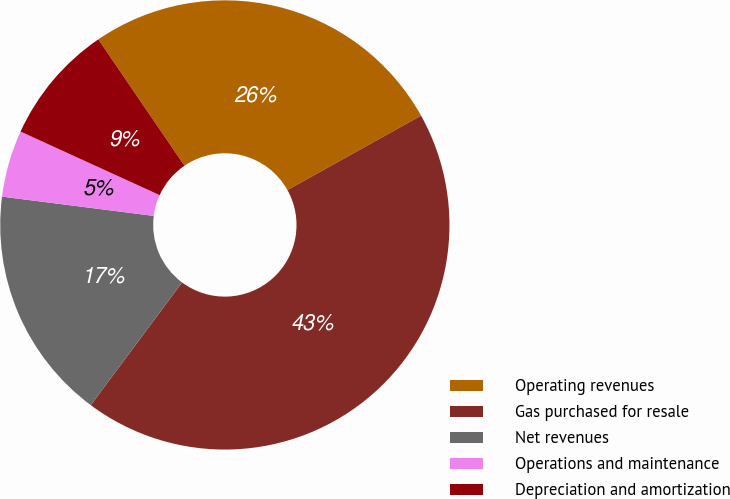<chart> <loc_0><loc_0><loc_500><loc_500><pie_chart><fcel>Operating revenues<fcel>Gas purchased for resale<fcel>Net revenues<fcel>Operations and maintenance<fcel>Depreciation and amortization<nl><fcel>26.44%<fcel>43.27%<fcel>16.83%<fcel>4.81%<fcel>8.65%<nl></chart> 